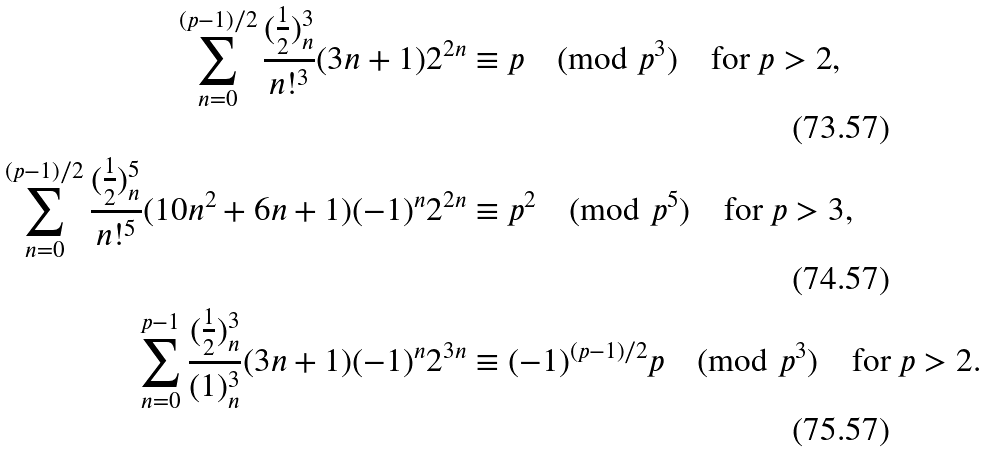Convert formula to latex. <formula><loc_0><loc_0><loc_500><loc_500>\sum _ { n = 0 } ^ { ( p - 1 ) / 2 } \frac { ( \frac { 1 } { 2 } ) _ { n } ^ { 3 } } { n ! ^ { 3 } } ( 3 n + 1 ) 2 ^ { 2 n } & \equiv p \pmod { p ^ { 3 } } \quad \text {for $p>2$} , \\ \sum _ { n = 0 } ^ { ( p - 1 ) / 2 } \frac { ( \frac { 1 } { 2 } ) _ { n } ^ { 5 } } { n ! ^ { 5 } } ( 1 0 n ^ { 2 } + 6 n + 1 ) ( - 1 ) ^ { n } 2 ^ { 2 n } & \equiv p ^ { 2 } \pmod { p ^ { 5 } } \quad \text {for $p>3$} , \\ \sum _ { n = 0 } ^ { p - 1 } \frac { ( \frac { 1 } { 2 } ) _ { n } ^ { 3 } } { ( 1 ) _ { n } ^ { 3 } } ( 3 n + 1 ) ( - 1 ) ^ { n } 2 ^ { 3 n } & \equiv ( - 1 ) ^ { ( p - 1 ) / 2 } p \pmod { p ^ { 3 } } \quad \text {for $p>2$} .</formula> 